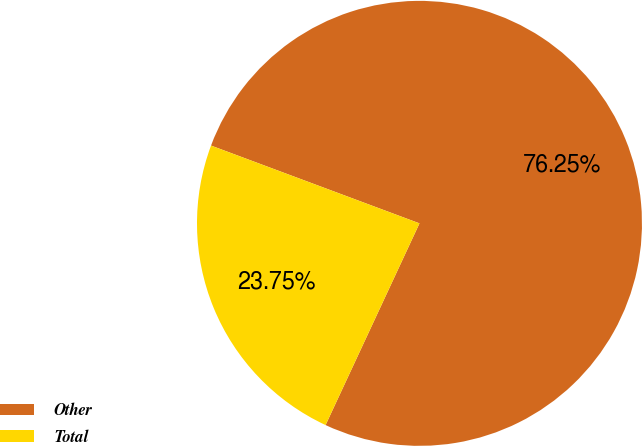Convert chart. <chart><loc_0><loc_0><loc_500><loc_500><pie_chart><fcel>Other<fcel>Total<nl><fcel>76.25%<fcel>23.75%<nl></chart> 